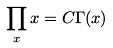<formula> <loc_0><loc_0><loc_500><loc_500>\prod _ { x } x = C \Gamma ( x )</formula> 